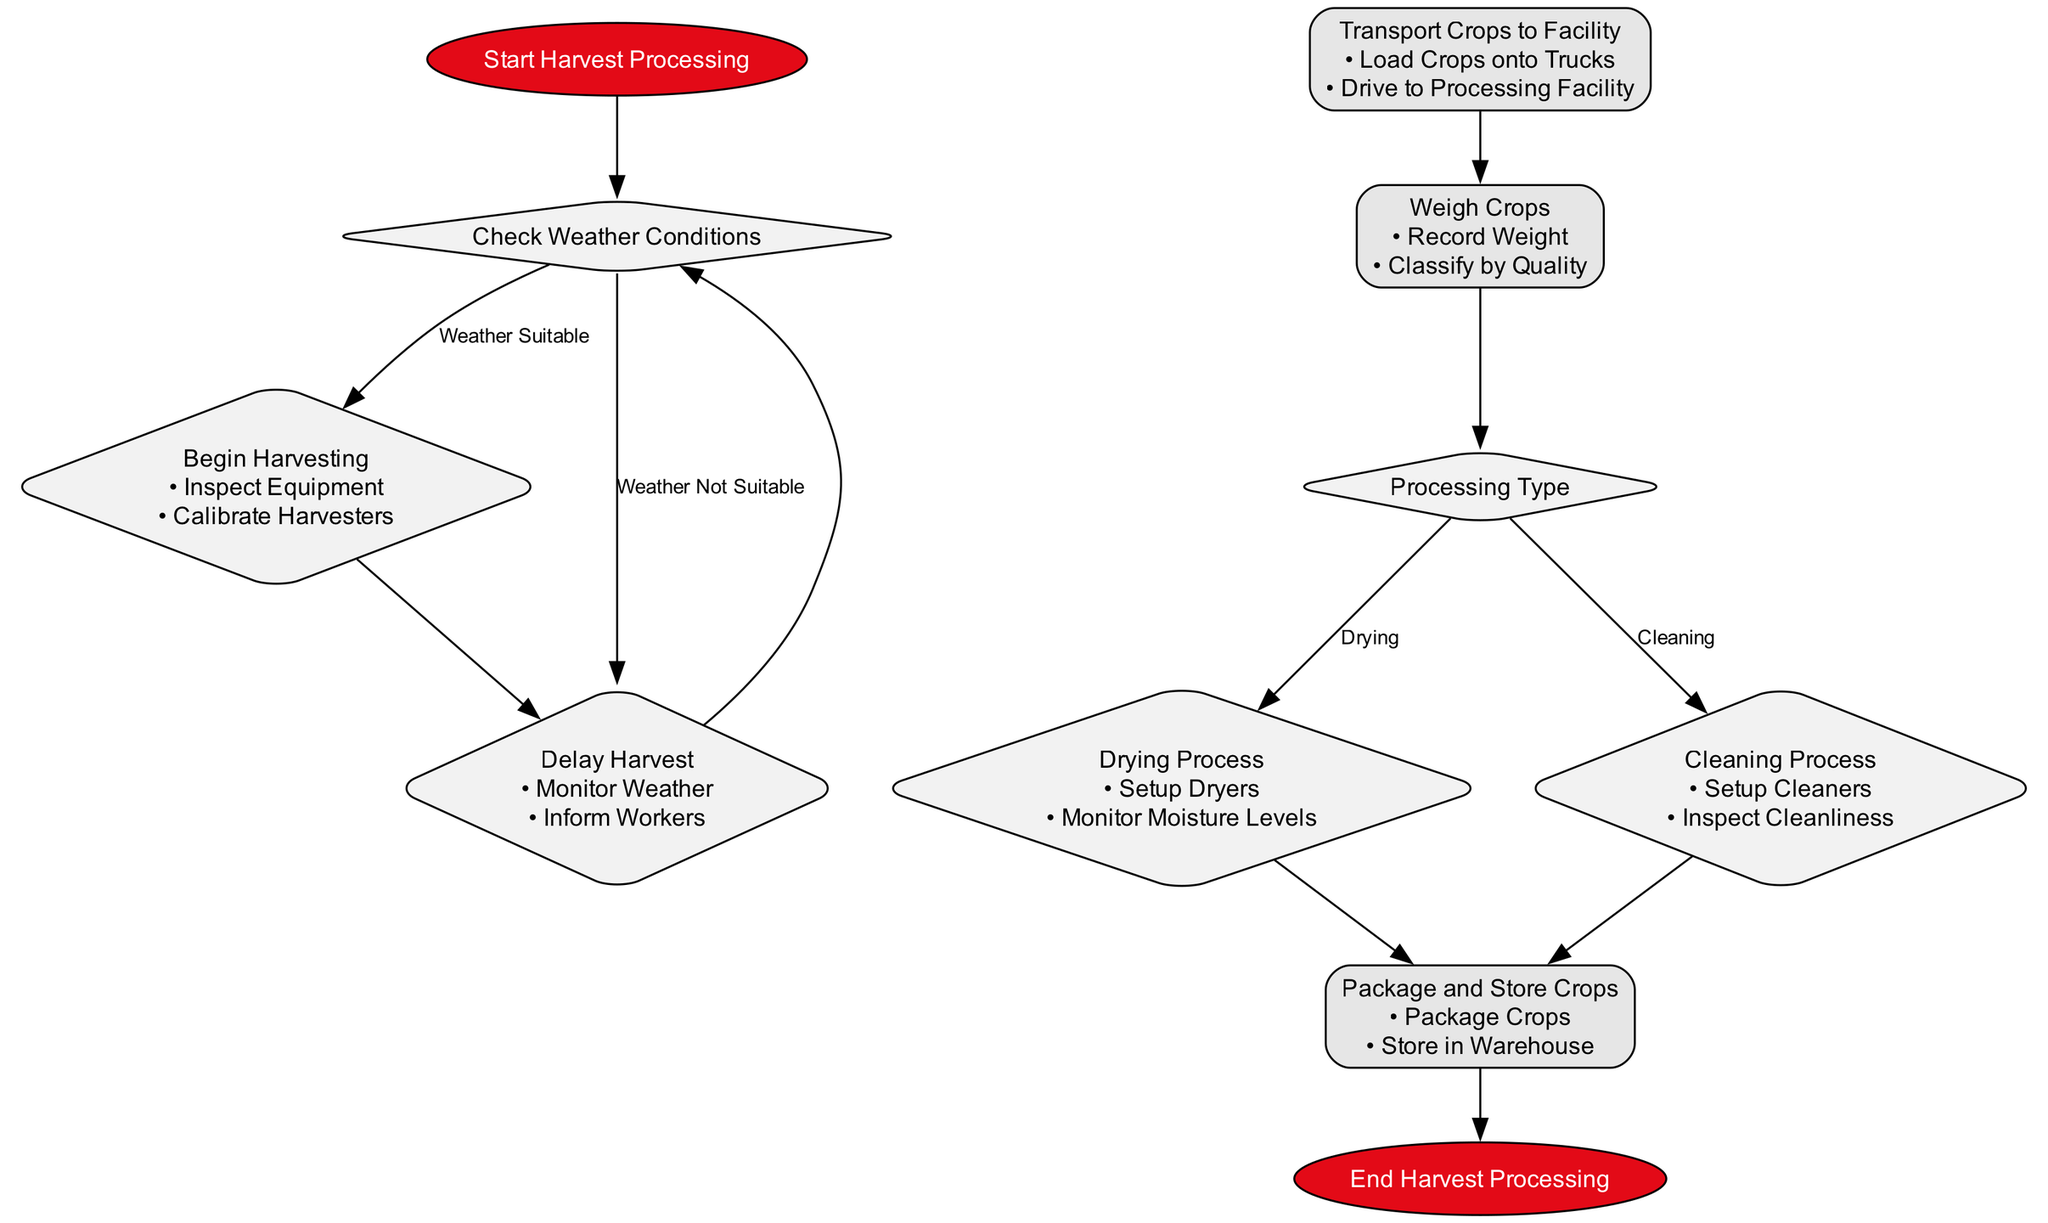What is the starting point of the workflow? The starting point of the workflow is labeled "Start Harvest Processing". This is indicated as the first element in the flowchart.
Answer: Start Harvest Processing What action is taken if the weather is suitable? If the weather is suitable, the process flows to "Begin Harvesting". This is represented as the first branch coming out of the "Check Weather Conditions" decision node.
Answer: Begin Harvesting How many main processing types are listed in the flowchart? There are two main processing types listed in the flowchart: "Drying" and "Cleaning". This can be seen as the two branches from the "Processing Type" decision node.
Answer: 2 What is the next step after the "Drying Process"? After the "Drying Process", the next step is "Package and Store Crops". This transition is shown in the flowchart where "Drying Process" leads directly to the next node without any decisions in between.
Answer: Package and Store Crops What happens if the weather is not suitable for harvesting? If the weather is not suitable, the process flows to "Delay Harvest". This outcome is indicated as the second branch of the "Check Weather Conditions" decision node.
Answer: Delay Harvest Which node comes after "Weigh Crops"? The node that comes after "Weigh Crops" is the "Processing Type" decision node. This is established from the flowchart structure where "Weigh Crops" directly leads to "Processing Type".
Answer: Processing Type What actions are performed during "Begin Harvesting"? During "Begin Harvesting", the actions performed are "Inspect Equipment" and "Calibrate Harvesters". This information is included in the label of the "Begin Harvesting" node.
Answer: Inspect Equipment, Calibrate Harvesters Which decision node follows after "Delay Harvest"? The decision node that follows "Delay Harvest" is "Check Weather Conditions", as the process loops back to assess the weather again after the delay.
Answer: Check Weather Conditions What is the final step of the workflow? The final step of the workflow is labeled "End Harvest Processing". This is shown as the last node in the diagram, concluding the entire process.
Answer: End Harvest Processing 